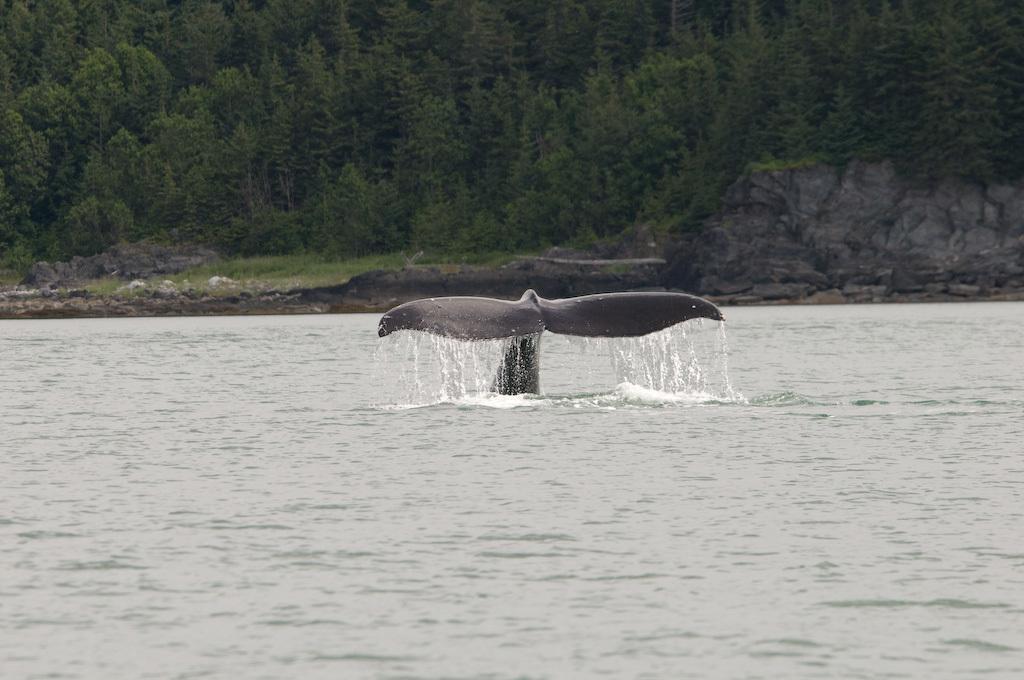In one or two sentences, can you explain what this image depicts? Here we can see water and water animal. Background there are trees. 